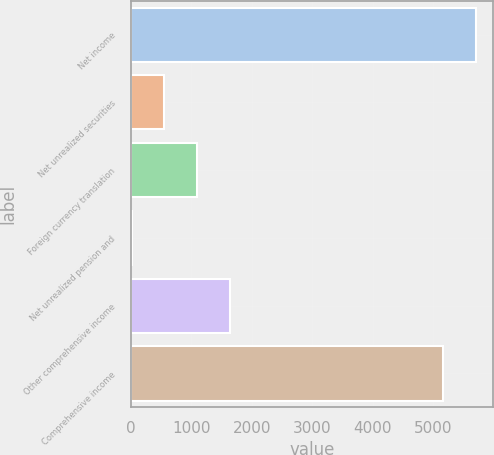Convert chart to OTSL. <chart><loc_0><loc_0><loc_500><loc_500><bar_chart><fcel>Net income<fcel>Net unrealized securities<fcel>Foreign currency translation<fcel>Net unrealized pension and<fcel>Other comprehensive income<fcel>Comprehensive income<nl><fcel>5696.9<fcel>557.9<fcel>1096.8<fcel>19<fcel>1635.7<fcel>5158<nl></chart> 